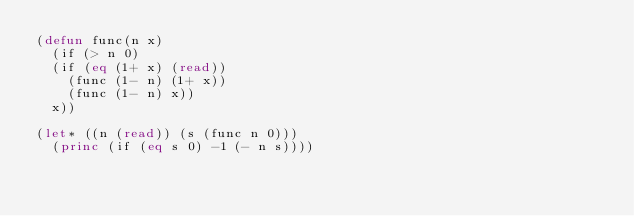Convert code to text. <code><loc_0><loc_0><loc_500><loc_500><_Lisp_>(defun func(n x)
  (if (> n 0)
	(if (eq (1+ x) (read))
	  (func (1- n) (1+ x))
	  (func (1- n) x))
	x))

(let* ((n (read)) (s (func n 0)))
  (princ (if (eq s 0) -1 (- n s))))
</code> 